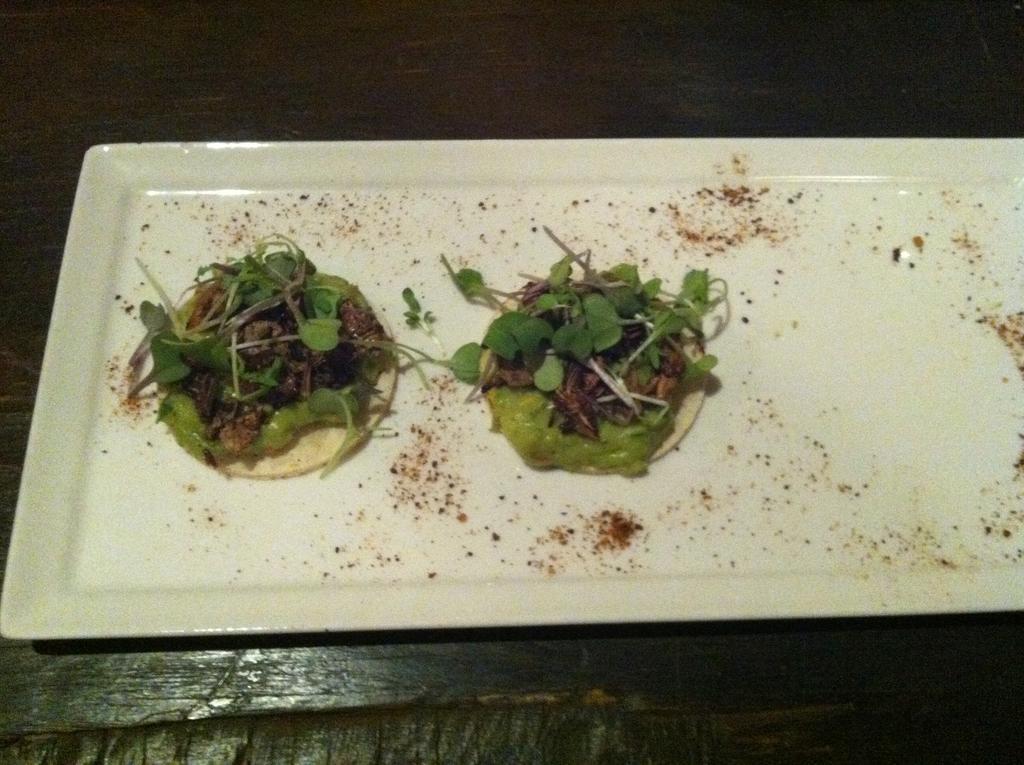Can you describe this image briefly? This image consists of food which is on the plate in the center 